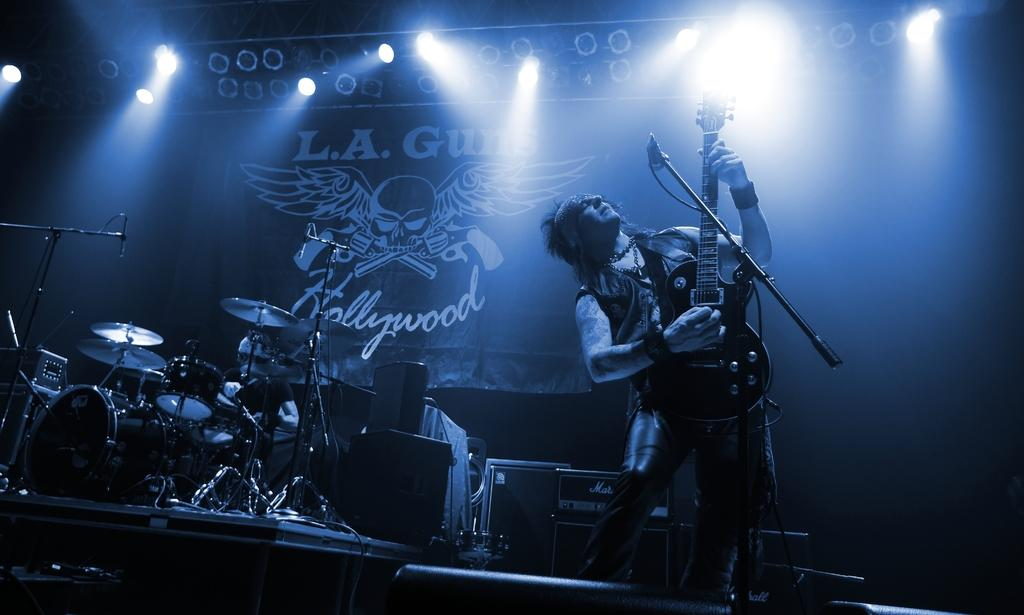What is the man in the image holding? The man is holding a guitar. What other musical instruments are visible in the image? There is a drum set in the image. What equipment might be used to amplify the sound of the instruments? There are speakers in the image. Where are all of these elements located in the image? All of these elements are on a stage. What type of design can be seen on the rose in the image? There is no rose present in the image. 